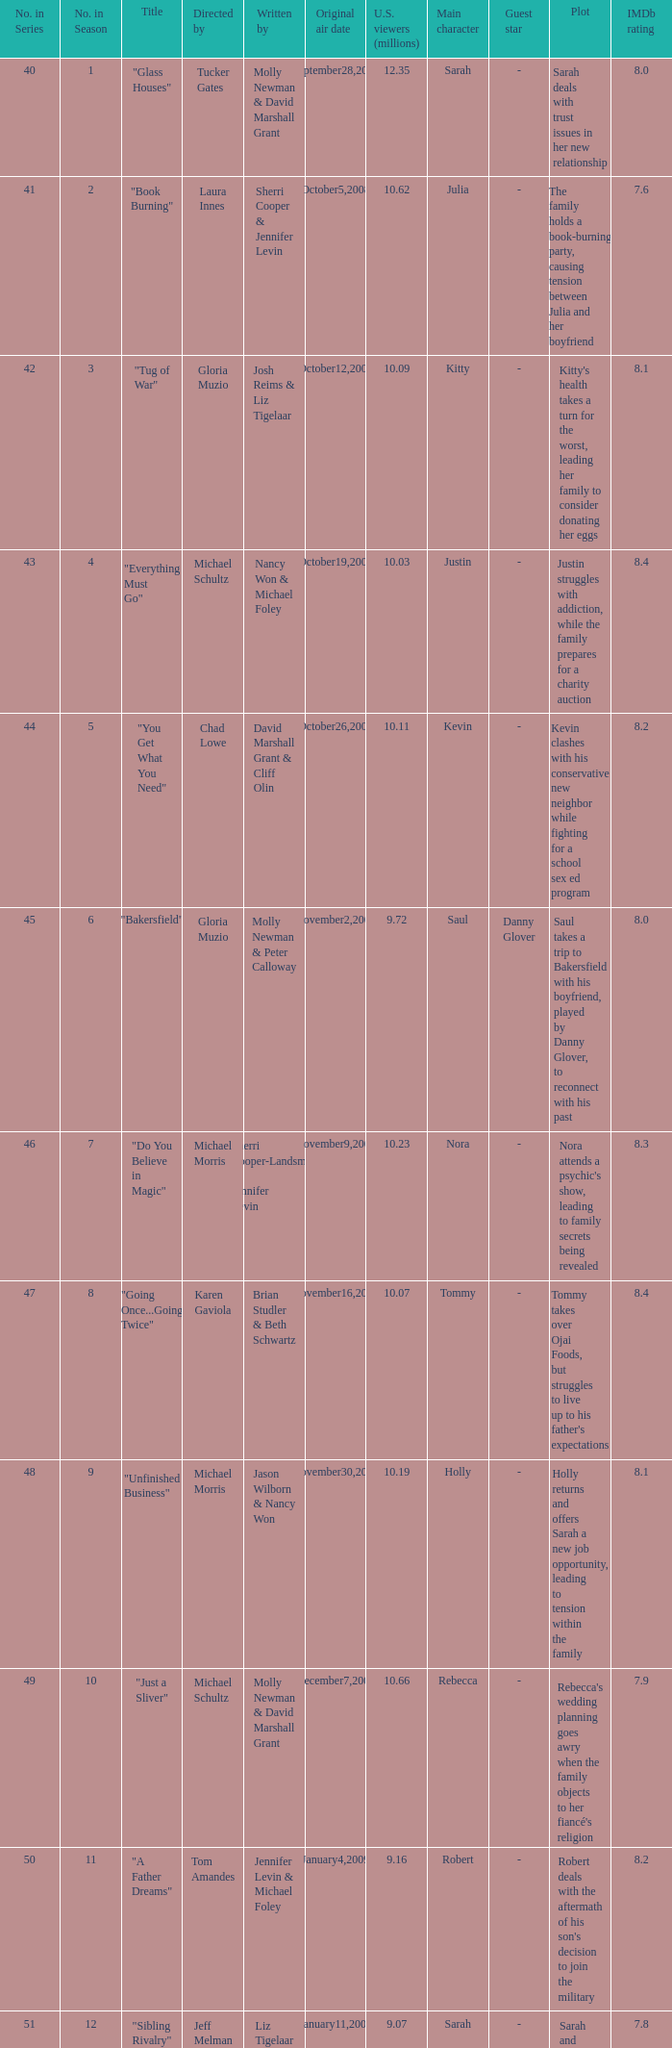When did the episode titled "Do you believe in magic" run for the first time? November9,2008. 